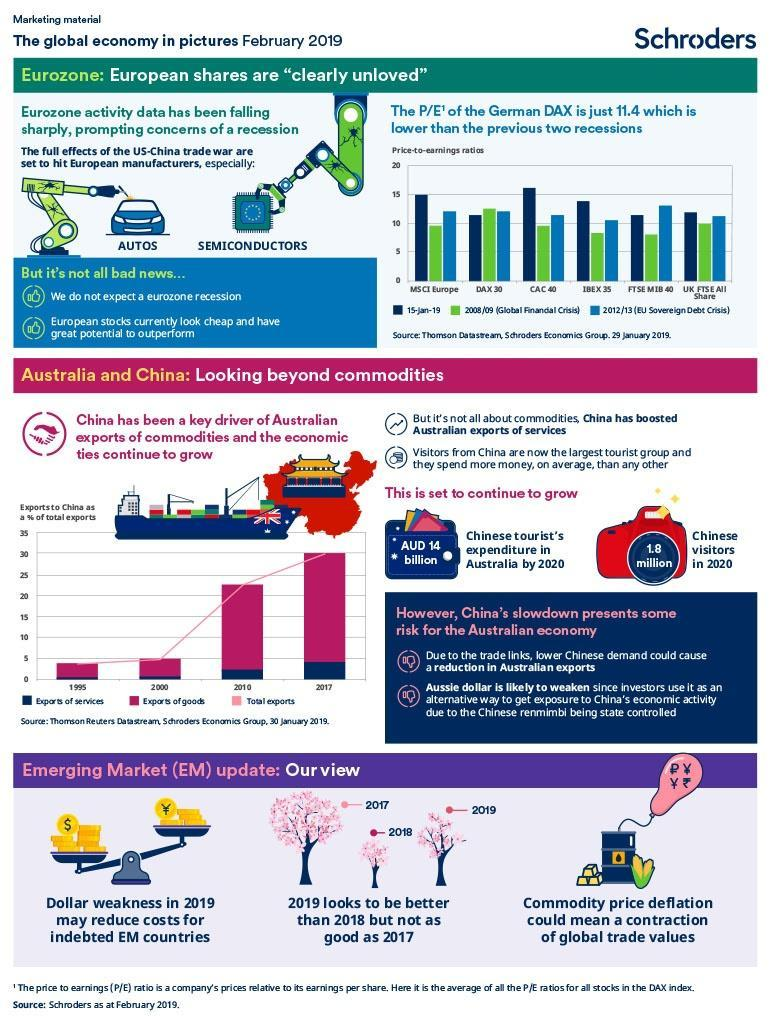What was the percentage of Exports of goods during 2000 according to the graph?
Answer the question with a short phrase. 5% During which year -2017, 2018 0r 2019 was the Emerging Market (EM) trend best? 2017 Which industries have been affected by US and China trade issues? AUTOS, SEMICONDUCTORS At what percent did the total exports reach during 2017 as per the graph? 30% During which year did the percentage of exports of services go high? 2017 What does P/E stand for? Price-to-earnings ratio 